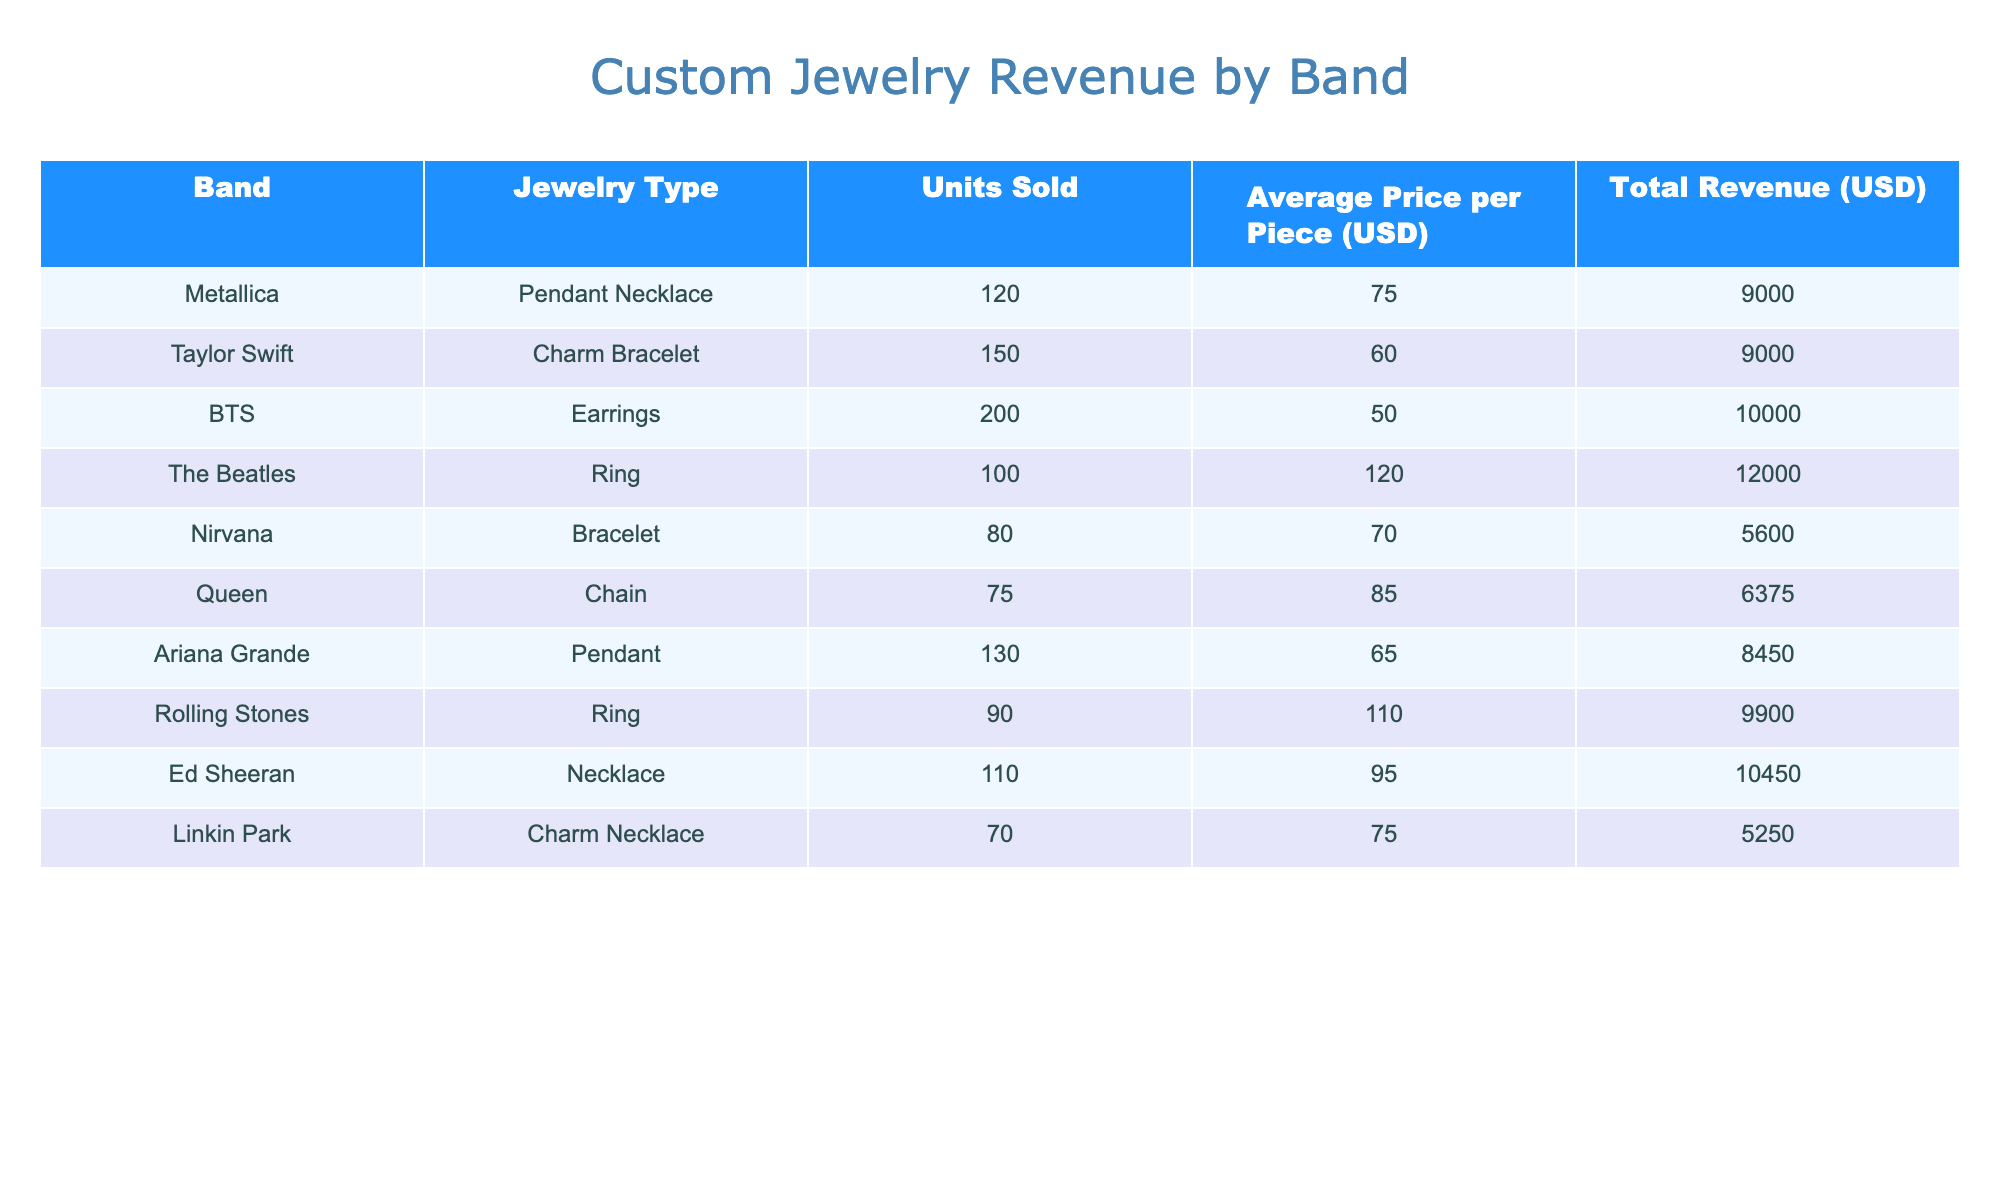What is the total revenue generated from Taylor Swift's jewelry? Taylor Swift's jewelry type is a Charm Bracelet. The Total Revenue for this item, as stated in the table, is 9000 USD.
Answer: 9000 USD Which band had the highest total revenue from their jewelry sales? The Total Revenue values are: Metallica (9000), Taylor Swift (9000), BTS (10000), The Beatles (12000), Nirvana (5600), Queen (6375), Ariana Grande (8450), Rolling Stones (9900), Ed Sheeran (10450), Linkin Park (5250). The highest total revenue is for The Beatles at 12000 USD.
Answer: The Beatles How many total units of jewelry were sold for Ed Sheeran and Linkin Park combined? Ed Sheeran sold 110 units and Linkin Park sold 70 units. To find the total, add 110 + 70 = 180 units.
Answer: 180 units Did Queen generate more total revenue than Metallica? Queen's Total Revenue is 6375 USD and Metallica's Total Revenue is 9000 USD. Since 6375 is less than 9000, Queen did not generate more revenue.
Answer: No What is the average price of a piece of jewelry sold for the bands Nirvana and BTS? Nirvana's average price is 70 USD, and BTS's average price is 50 USD. To find the average, sum them (70 + 50 = 120) and divide by the number of bands (2), resulting in 120 / 2 = 60 USD.
Answer: 60 USD Which band has the lowest total revenue, and what is that revenue? The Total Revenues are: Metallica (9000), Taylor Swift (9000), BTS (10000), The Beatles (12000), Nirvana (5600), Queen (6375), Ariana Grande (8450), Rolling Stones (9900), Ed Sheeran (10450), Linkin Park (5250). The lowest is from Linkin Park with a revenue of 5250 USD.
Answer: Linkin Park, 5250 USD What is the difference in total revenue between The Beatles and Ed Sheeran? The Beatles generated 12000 USD while Ed Sheeran generated 10450 USD. The difference is 12000 - 10450 = 1550 USD.
Answer: 1550 USD If we combine the sales of all the jewelry types for bands with "Necklace" in their name, what is their total revenue? The bands with "Necklace" are Ed Sheeran (10450) and Metallica (9000) with pendants. The total revenue is 10450 + 9000 = 19450 USD.
Answer: 19450 USD 